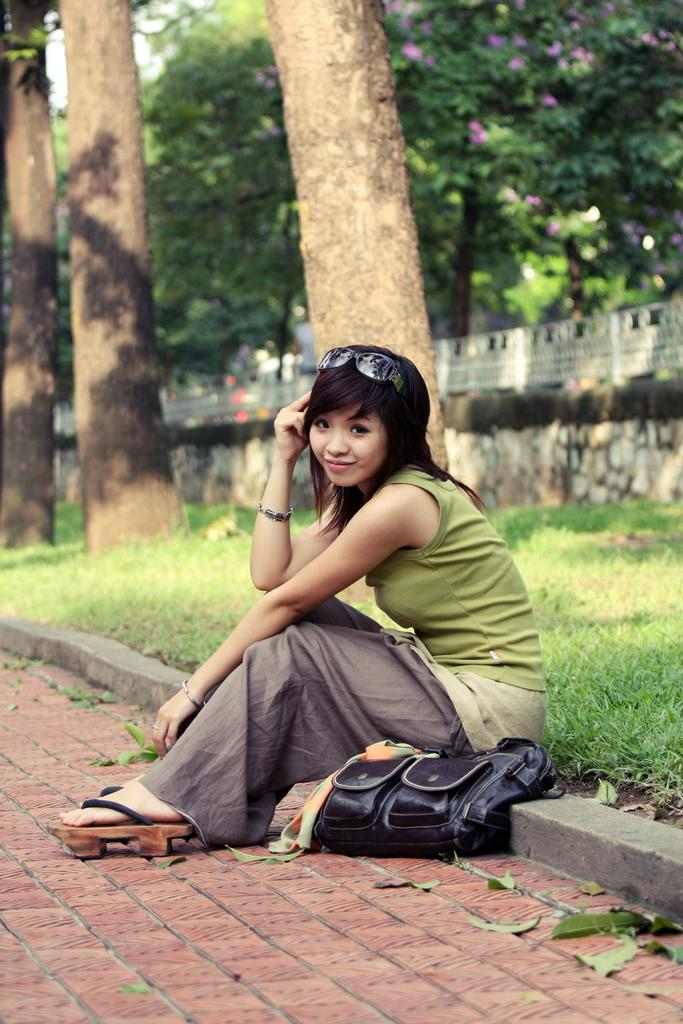Who is present in the image? There is a woman in the image. What is the woman doing in the image? The woman is seated. What object is beside the woman? There is a bag beside the woman. What can be seen in the background of the image? There are trees and grass in the background of the image. What accessory is visible on the woman in the image? There are spectacles visible in the image. What type of plants are being used to make a quilt in the image? There is no quilt or plants being used to make a quilt in the image. Is the woman in the image being held in a prison? There is no indication of a prison or any confinement in the image; the woman is seated outdoors with trees and grass in the background. 